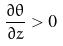Convert formula to latex. <formula><loc_0><loc_0><loc_500><loc_500>\frac { \partial \theta } { \partial z } > 0</formula> 